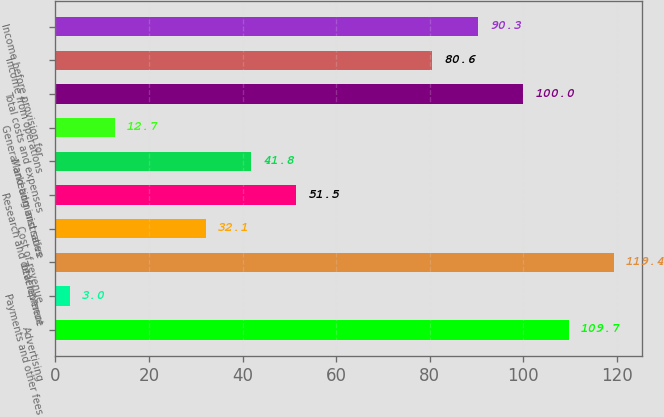Convert chart. <chart><loc_0><loc_0><loc_500><loc_500><bar_chart><fcel>Advertising<fcel>Payments and other fees<fcel>Total revenue<fcel>Cost of revenue<fcel>Research and development<fcel>Marketing and sales<fcel>General and administrative<fcel>Total costs and expenses<fcel>Income from operations<fcel>Income before provision for<nl><fcel>109.7<fcel>3<fcel>119.4<fcel>32.1<fcel>51.5<fcel>41.8<fcel>12.7<fcel>100<fcel>80.6<fcel>90.3<nl></chart> 